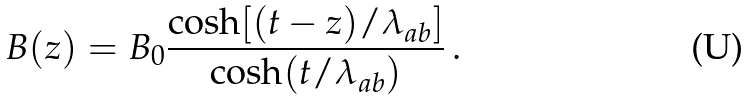<formula> <loc_0><loc_0><loc_500><loc_500>B ( z ) = B _ { 0 } \frac { \cosh [ ( t - z ) / \lambda _ { a b } ] } { \cosh ( t / \lambda _ { a b } ) } \, .</formula> 